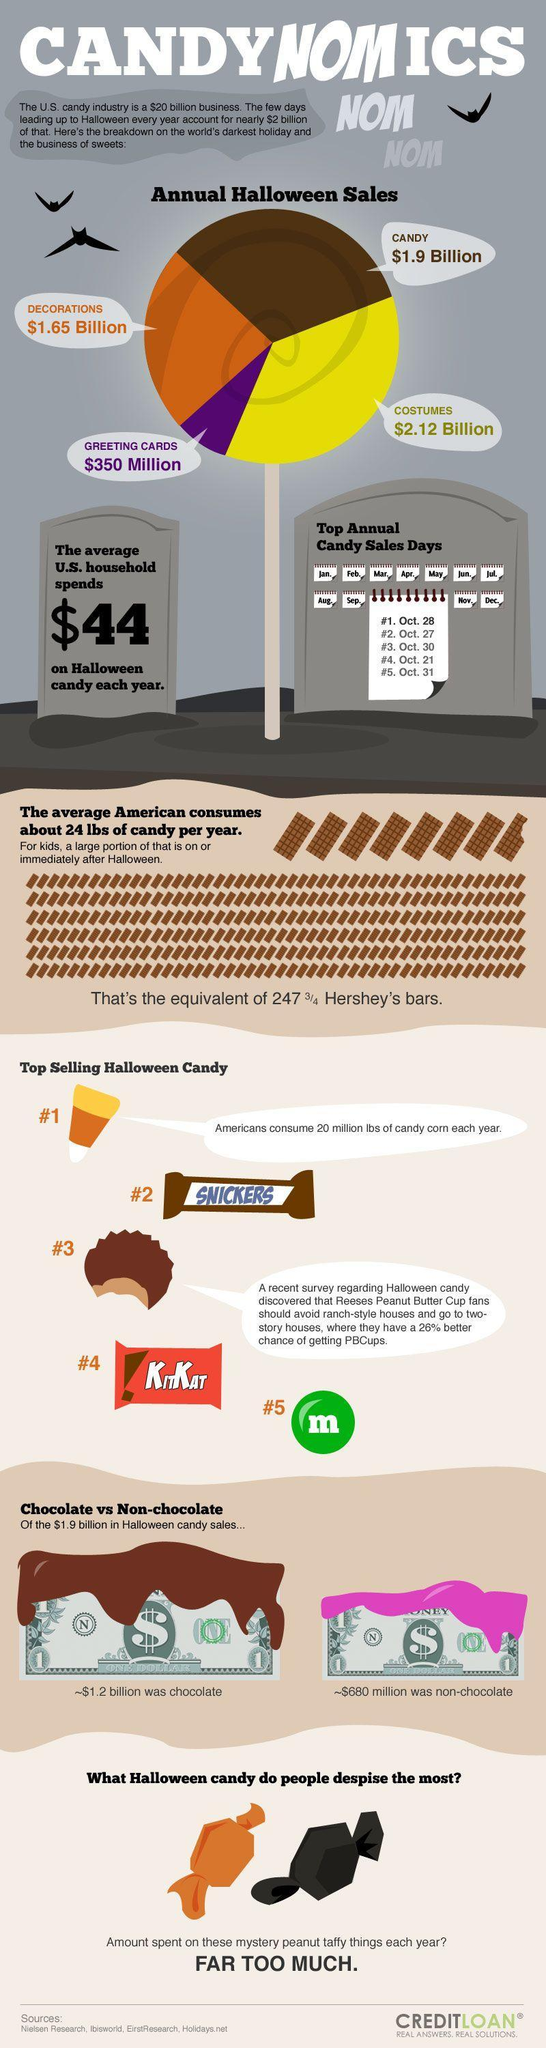Which is the Halloween Candy shown in the info graphic whose wrappers background color is red?
Answer the question with a short phrase. KitKat Which item has third highest no of sales in Annual Halloween sales? Decorations Which is the second most selling Halloween candy? Snickers Which item has second highest no of sales in Annual Halloween sales? Candy 